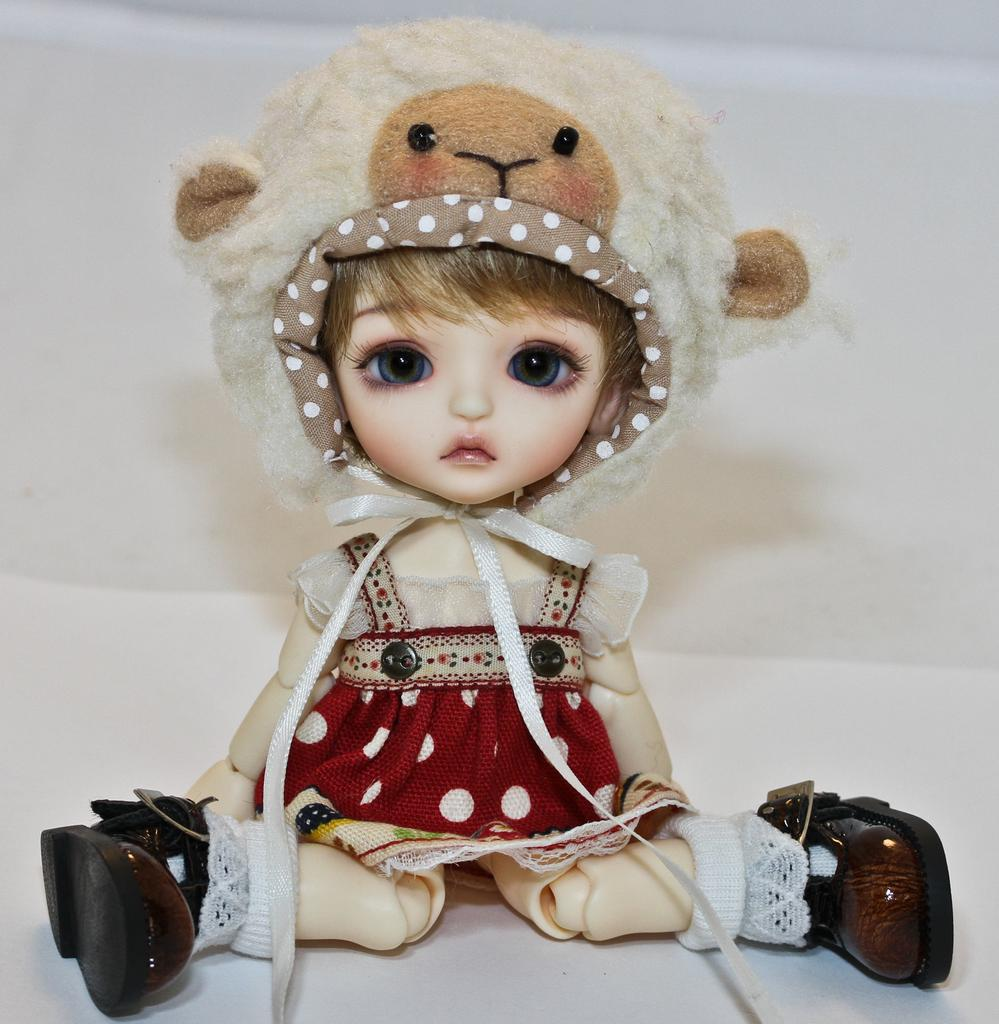What is the main subject of the image? There is a doll in the image. What is the doll wearing? The doll is wearing clothes, shoes, and a cap. What is the doll sitting on? The doll is sitting on a white surface and a wall. What type of notebook is the doll holding in the image? There is no notebook present in the image; the doll is not holding anything. 